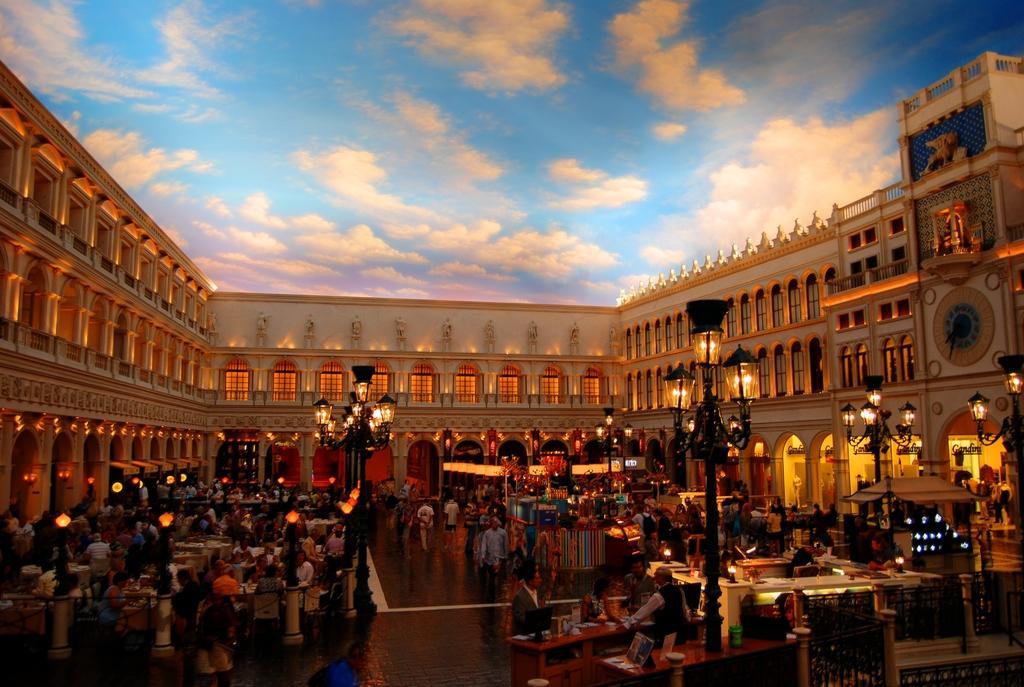Could you give a brief overview of what you see in this image? In this picture I can see many people who are standing near to the tables and some peoples are sitting on the chair. In the center I can see some other peoples who are walking on this line. At the bottom I can see the street lights. In the background I can see the building. At the top I can see the sky and clouds. 